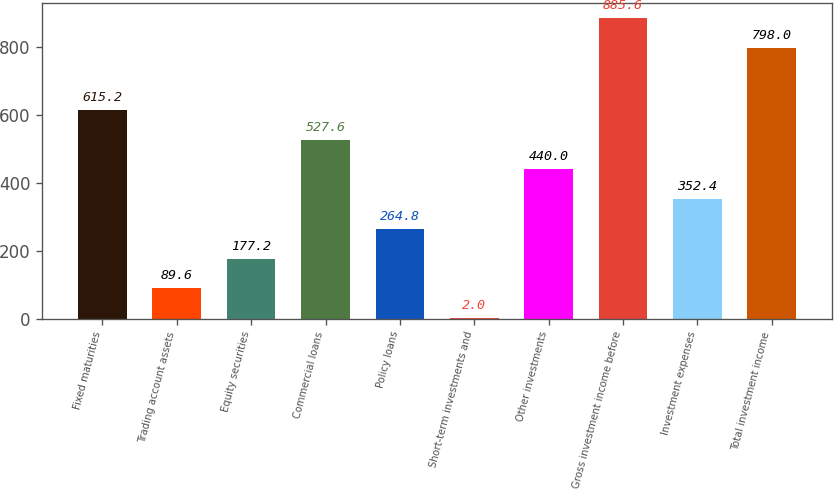Convert chart to OTSL. <chart><loc_0><loc_0><loc_500><loc_500><bar_chart><fcel>Fixed maturities<fcel>Trading account assets<fcel>Equity securities<fcel>Commercial loans<fcel>Policy loans<fcel>Short-term investments and<fcel>Other investments<fcel>Gross investment income before<fcel>Investment expenses<fcel>Total investment income<nl><fcel>615.2<fcel>89.6<fcel>177.2<fcel>527.6<fcel>264.8<fcel>2<fcel>440<fcel>885.6<fcel>352.4<fcel>798<nl></chart> 